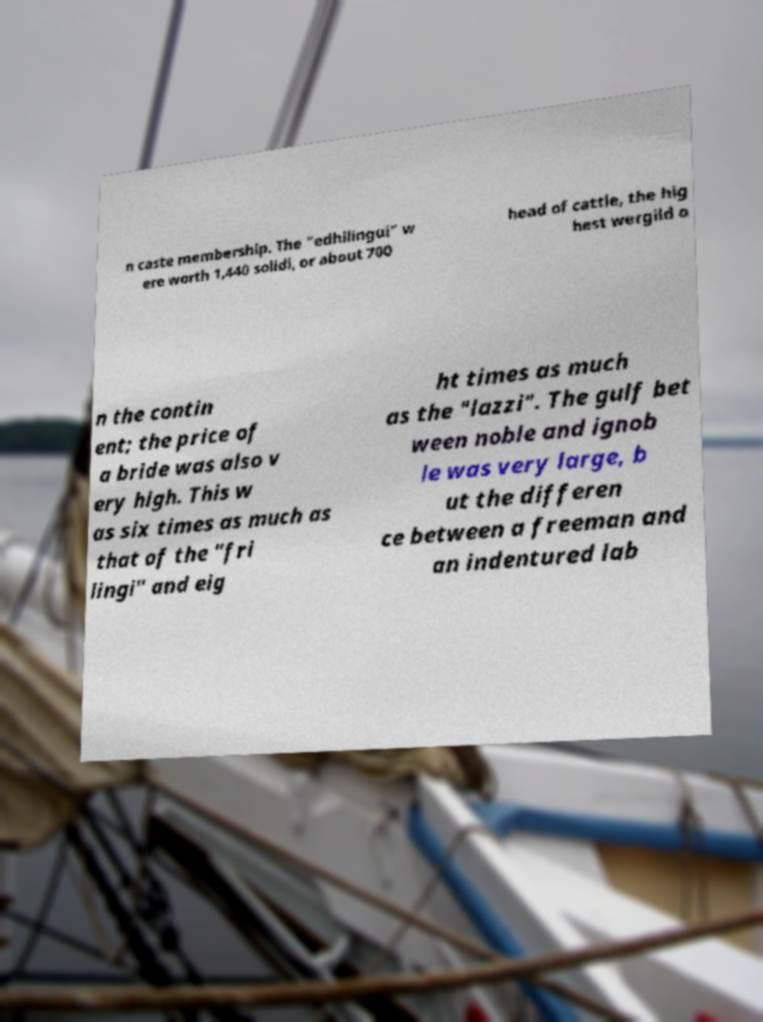Can you read and provide the text displayed in the image?This photo seems to have some interesting text. Can you extract and type it out for me? n caste membership. The "edhilingui" w ere worth 1,440 solidi, or about 700 head of cattle, the hig hest wergild o n the contin ent; the price of a bride was also v ery high. This w as six times as much as that of the "fri lingi" and eig ht times as much as the "lazzi". The gulf bet ween noble and ignob le was very large, b ut the differen ce between a freeman and an indentured lab 